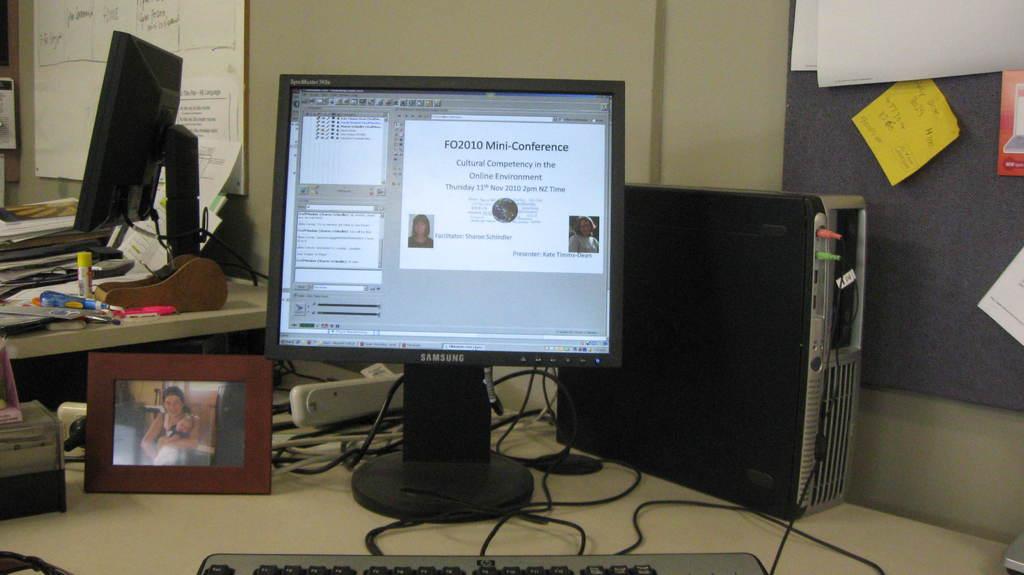What brand of computer is this?
Your answer should be compact. Samsung. What is the topic of the conference?
Make the answer very short. Cultural competency in the online environment . 